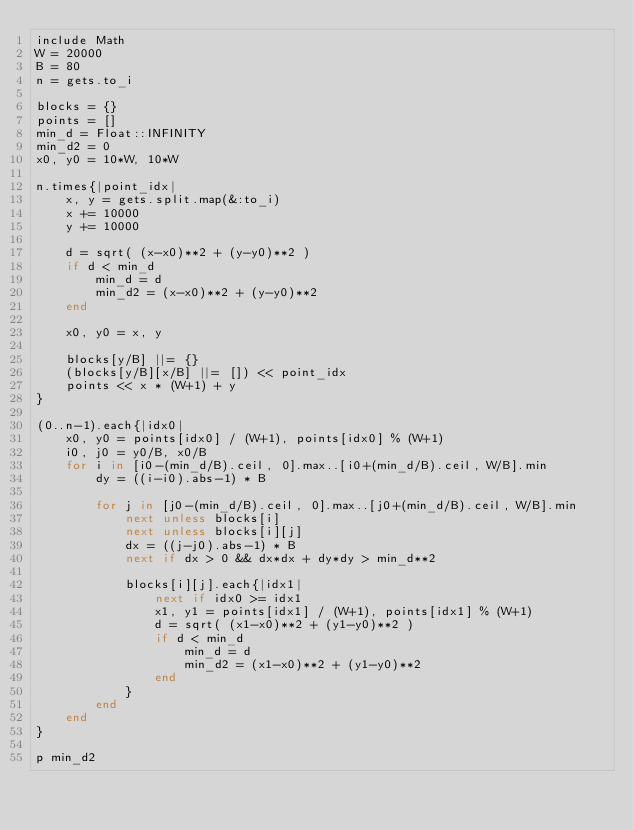<code> <loc_0><loc_0><loc_500><loc_500><_Ruby_>include Math
W = 20000
B = 80
n = gets.to_i

blocks = {}
points = []
min_d = Float::INFINITY
min_d2 = 0
x0, y0 = 10*W, 10*W

n.times{|point_idx|
	x, y = gets.split.map(&:to_i)
	x += 10000
	y += 10000

	d = sqrt( (x-x0)**2 + (y-y0)**2 )
	if d < min_d
		min_d = d
		min_d2 = (x-x0)**2 + (y-y0)**2
	end

	x0, y0 = x, y

	blocks[y/B] ||= {}
	(blocks[y/B][x/B] ||= []) << point_idx
	points << x * (W+1) + y
}

(0..n-1).each{|idx0|
	x0, y0 = points[idx0] / (W+1), points[idx0] % (W+1)
	i0, j0 = y0/B, x0/B
	for i in [i0-(min_d/B).ceil, 0].max..[i0+(min_d/B).ceil, W/B].min
		dy = ((i-i0).abs-1) * B

		for j in [j0-(min_d/B).ceil, 0].max..[j0+(min_d/B).ceil, W/B].min
			next unless blocks[i]
			next unless blocks[i][j]
			dx = ((j-j0).abs-1) * B
			next if dx > 0 && dx*dx + dy*dy > min_d**2

			blocks[i][j].each{|idx1|
				next if idx0 >= idx1
				x1, y1 = points[idx1] / (W+1), points[idx1] % (W+1)
				d = sqrt( (x1-x0)**2 + (y1-y0)**2 )
				if d < min_d
					min_d = d
					min_d2 = (x1-x0)**2 + (y1-y0)**2
				end
			}
		end
	end
}

p min_d2</code> 